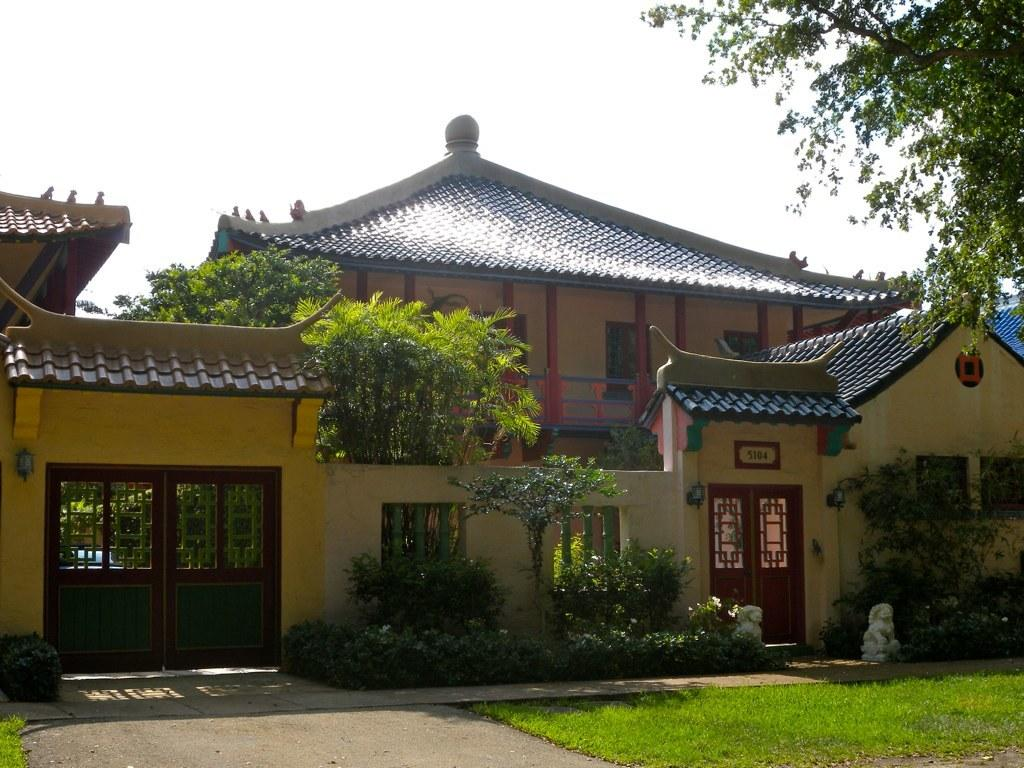What type of structure is visible in the image? There is a building in the image. What can be seen near the building? Trees and plants are present near the building. What type of surface is in front of the building? There is a grass surface in front of the building. What other natural elements are visible in the image? There is a tree in the image. What is visible in the background of the image? The sky is visible in the background of the image. How many babies are playing with a patch and net in the image? There are no babies, patches, or nets present in the image. 